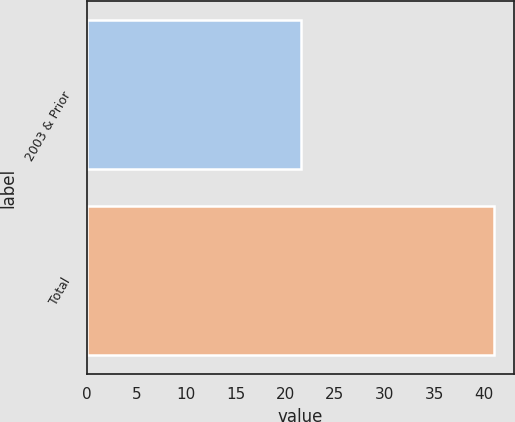<chart> <loc_0><loc_0><loc_500><loc_500><bar_chart><fcel>2003 & Prior<fcel>Total<nl><fcel>21.6<fcel>41<nl></chart> 